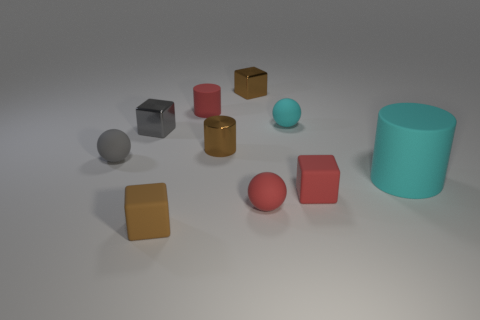Subtract all cylinders. How many objects are left? 7 Add 5 tiny brown shiny cubes. How many tiny brown shiny cubes are left? 6 Add 3 large rubber cylinders. How many large rubber cylinders exist? 4 Subtract 0 yellow spheres. How many objects are left? 10 Subtract all tiny cylinders. Subtract all small shiny cylinders. How many objects are left? 7 